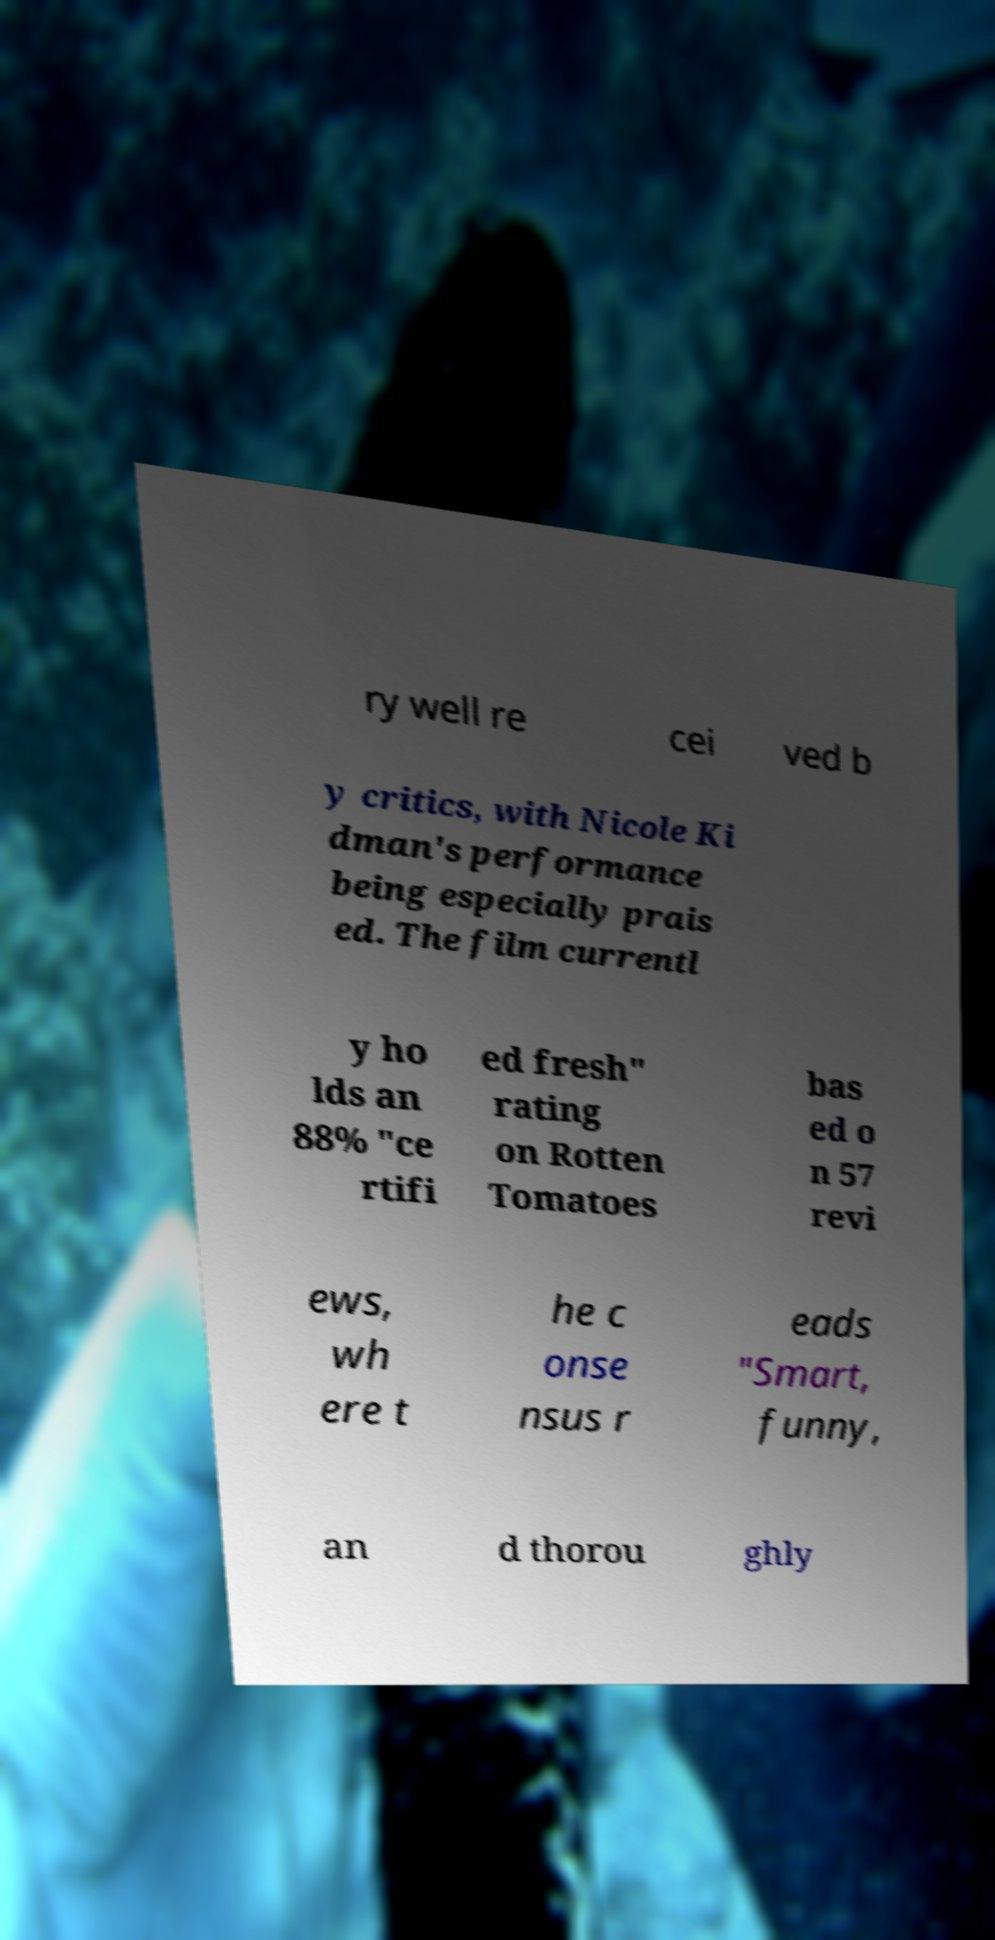Could you assist in decoding the text presented in this image and type it out clearly? ry well re cei ved b y critics, with Nicole Ki dman's performance being especially prais ed. The film currentl y ho lds an 88% "ce rtifi ed fresh" rating on Rotten Tomatoes bas ed o n 57 revi ews, wh ere t he c onse nsus r eads "Smart, funny, an d thorou ghly 